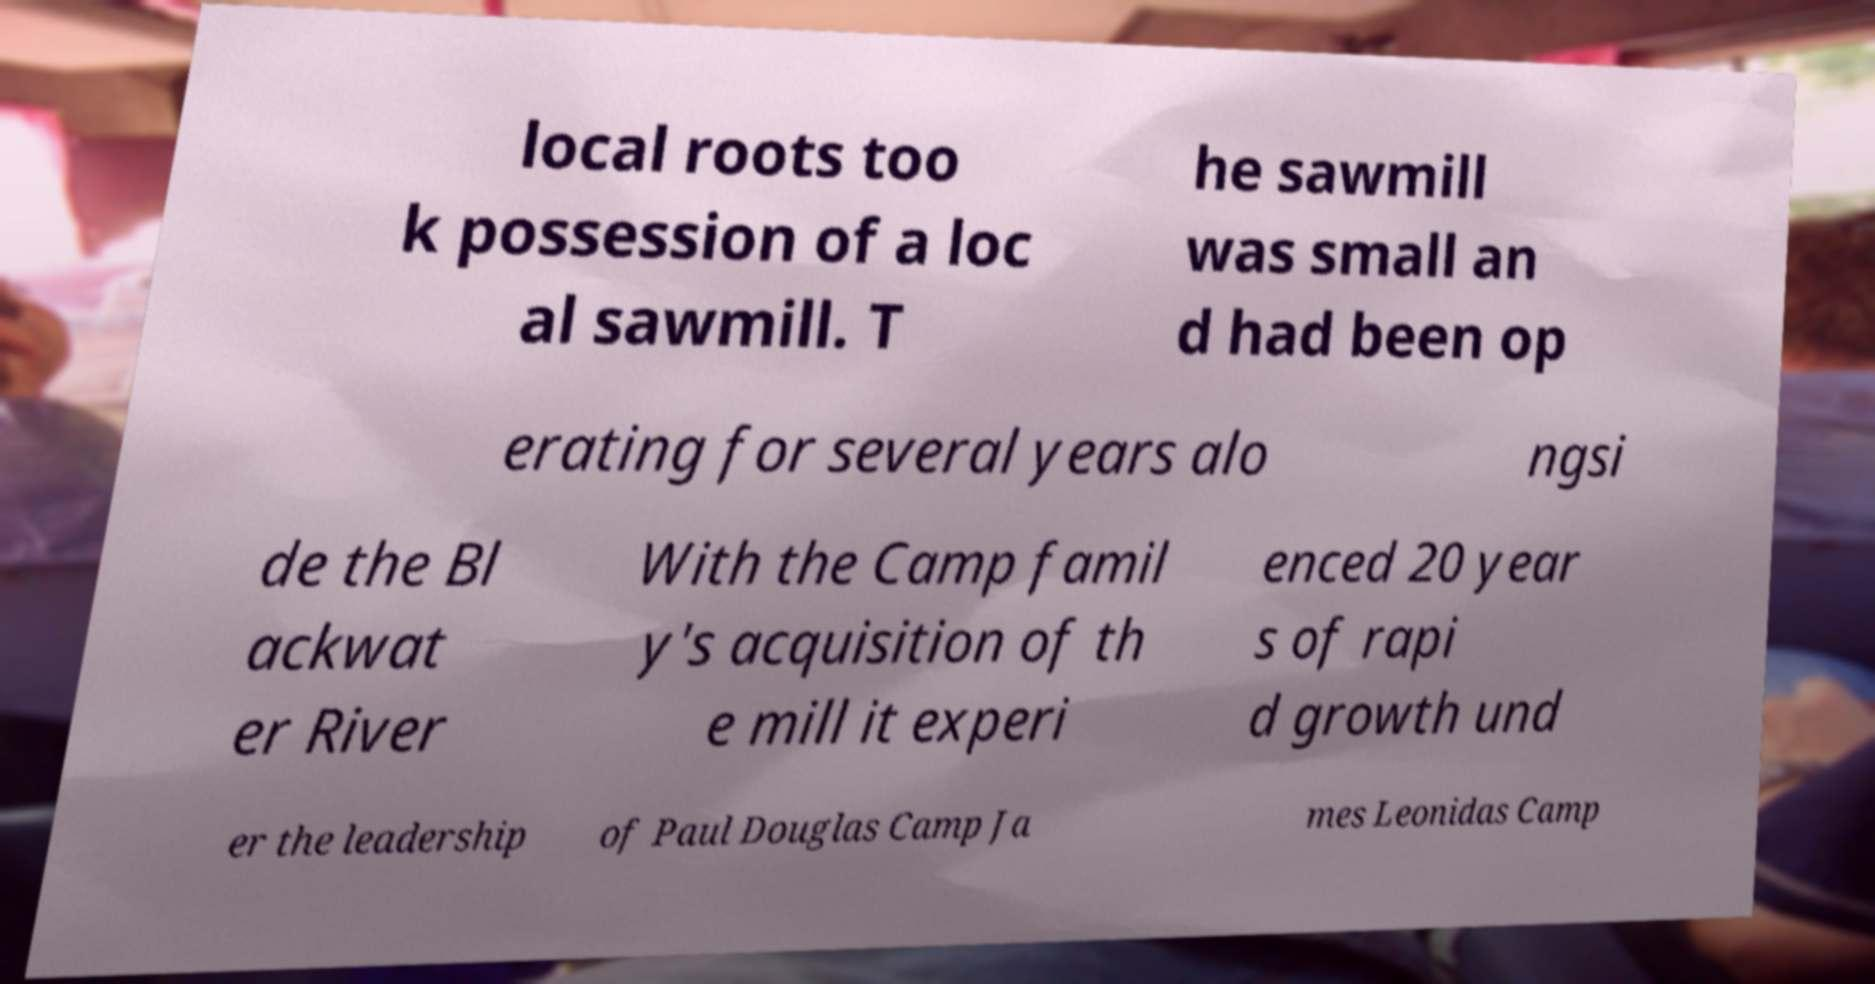What messages or text are displayed in this image? I need them in a readable, typed format. local roots too k possession of a loc al sawmill. T he sawmill was small an d had been op erating for several years alo ngsi de the Bl ackwat er River With the Camp famil y's acquisition of th e mill it experi enced 20 year s of rapi d growth und er the leadership of Paul Douglas Camp Ja mes Leonidas Camp 